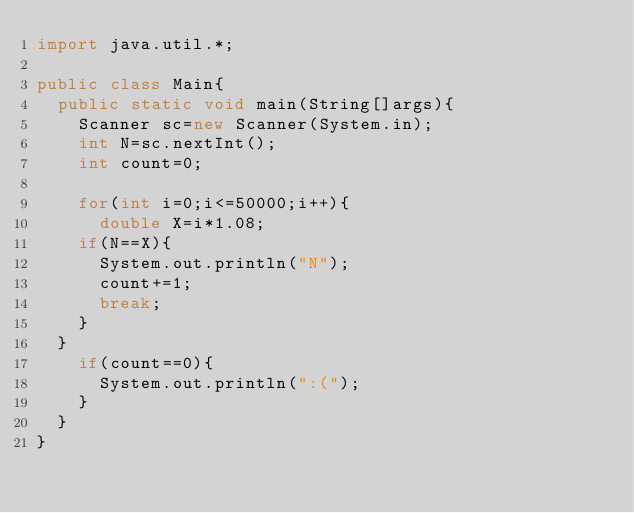Convert code to text. <code><loc_0><loc_0><loc_500><loc_500><_Java_>import java.util.*;

public class Main{
  public static void main(String[]args){
    Scanner sc=new Scanner(System.in);
    int N=sc.nextInt();
    int count=0;
    
    for(int i=0;i<=50000;i++){
      double X=i*1.08;
    if(N==X){
      System.out.println("N");
      count+=1;
      break;
    }
  }
    if(count==0){
      System.out.println(":(");
    }
  }
}
  
</code> 